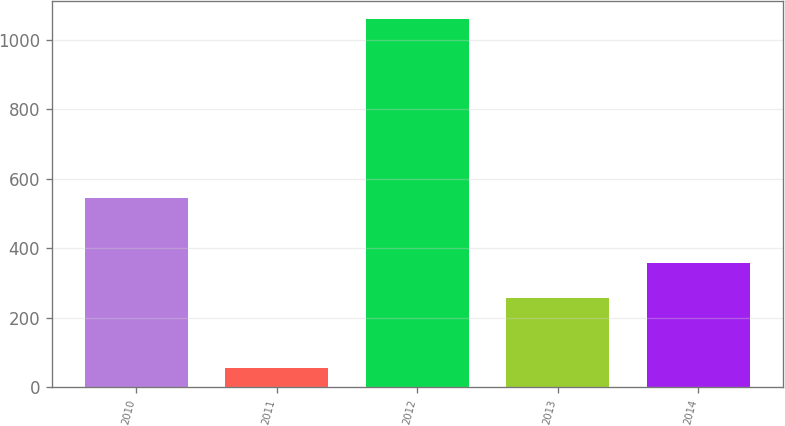Convert chart. <chart><loc_0><loc_0><loc_500><loc_500><bar_chart><fcel>2010<fcel>2011<fcel>2012<fcel>2013<fcel>2014<nl><fcel>544<fcel>54<fcel>1060<fcel>258<fcel>358.6<nl></chart> 